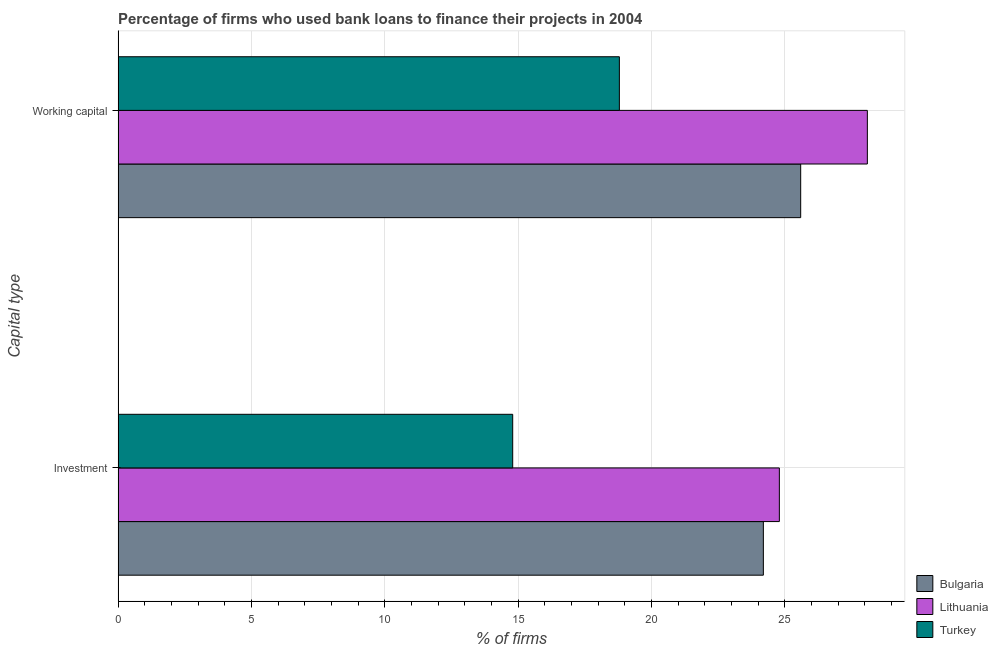How many different coloured bars are there?
Keep it short and to the point. 3. How many groups of bars are there?
Your answer should be very brief. 2. Are the number of bars per tick equal to the number of legend labels?
Your answer should be compact. Yes. Are the number of bars on each tick of the Y-axis equal?
Ensure brevity in your answer.  Yes. How many bars are there on the 1st tick from the bottom?
Ensure brevity in your answer.  3. What is the label of the 2nd group of bars from the top?
Keep it short and to the point. Investment. What is the percentage of firms using banks to finance investment in Lithuania?
Ensure brevity in your answer.  24.8. Across all countries, what is the maximum percentage of firms using banks to finance working capital?
Your answer should be very brief. 28.1. In which country was the percentage of firms using banks to finance investment maximum?
Provide a short and direct response. Lithuania. In which country was the percentage of firms using banks to finance working capital minimum?
Your answer should be compact. Turkey. What is the total percentage of firms using banks to finance working capital in the graph?
Give a very brief answer. 72.5. What is the difference between the percentage of firms using banks to finance investment in Bulgaria and the percentage of firms using banks to finance working capital in Turkey?
Make the answer very short. 5.4. What is the average percentage of firms using banks to finance working capital per country?
Offer a very short reply. 24.17. What is the ratio of the percentage of firms using banks to finance investment in Bulgaria to that in Lithuania?
Offer a terse response. 0.98. In how many countries, is the percentage of firms using banks to finance working capital greater than the average percentage of firms using banks to finance working capital taken over all countries?
Your answer should be compact. 2. What does the 2nd bar from the top in Working capital represents?
Make the answer very short. Lithuania. What does the 2nd bar from the bottom in Working capital represents?
Your response must be concise. Lithuania. How many bars are there?
Your answer should be very brief. 6. Does the graph contain grids?
Give a very brief answer. Yes. Where does the legend appear in the graph?
Offer a terse response. Bottom right. How many legend labels are there?
Provide a short and direct response. 3. What is the title of the graph?
Your answer should be compact. Percentage of firms who used bank loans to finance their projects in 2004. What is the label or title of the X-axis?
Make the answer very short. % of firms. What is the label or title of the Y-axis?
Your answer should be very brief. Capital type. What is the % of firms in Bulgaria in Investment?
Your answer should be very brief. 24.2. What is the % of firms of Lithuania in Investment?
Provide a succinct answer. 24.8. What is the % of firms in Turkey in Investment?
Give a very brief answer. 14.8. What is the % of firms in Bulgaria in Working capital?
Ensure brevity in your answer.  25.6. What is the % of firms in Lithuania in Working capital?
Your answer should be very brief. 28.1. What is the % of firms in Turkey in Working capital?
Keep it short and to the point. 18.8. Across all Capital type, what is the maximum % of firms of Bulgaria?
Your answer should be compact. 25.6. Across all Capital type, what is the maximum % of firms of Lithuania?
Your answer should be very brief. 28.1. Across all Capital type, what is the maximum % of firms in Turkey?
Your answer should be very brief. 18.8. Across all Capital type, what is the minimum % of firms in Bulgaria?
Your response must be concise. 24.2. Across all Capital type, what is the minimum % of firms in Lithuania?
Give a very brief answer. 24.8. Across all Capital type, what is the minimum % of firms in Turkey?
Offer a terse response. 14.8. What is the total % of firms in Bulgaria in the graph?
Provide a succinct answer. 49.8. What is the total % of firms of Lithuania in the graph?
Ensure brevity in your answer.  52.9. What is the total % of firms of Turkey in the graph?
Your response must be concise. 33.6. What is the difference between the % of firms of Lithuania in Investment and that in Working capital?
Your answer should be very brief. -3.3. What is the average % of firms of Bulgaria per Capital type?
Your response must be concise. 24.9. What is the average % of firms of Lithuania per Capital type?
Keep it short and to the point. 26.45. What is the average % of firms of Turkey per Capital type?
Offer a terse response. 16.8. What is the difference between the % of firms of Bulgaria and % of firms of Lithuania in Investment?
Your answer should be very brief. -0.6. What is the difference between the % of firms of Bulgaria and % of firms of Turkey in Investment?
Give a very brief answer. 9.4. What is the difference between the % of firms in Bulgaria and % of firms in Lithuania in Working capital?
Make the answer very short. -2.5. What is the difference between the % of firms of Bulgaria and % of firms of Turkey in Working capital?
Your response must be concise. 6.8. What is the difference between the % of firms in Lithuania and % of firms in Turkey in Working capital?
Offer a terse response. 9.3. What is the ratio of the % of firms in Bulgaria in Investment to that in Working capital?
Make the answer very short. 0.95. What is the ratio of the % of firms in Lithuania in Investment to that in Working capital?
Provide a succinct answer. 0.88. What is the ratio of the % of firms in Turkey in Investment to that in Working capital?
Keep it short and to the point. 0.79. What is the difference between the highest and the second highest % of firms of Turkey?
Offer a terse response. 4. What is the difference between the highest and the lowest % of firms in Lithuania?
Make the answer very short. 3.3. 